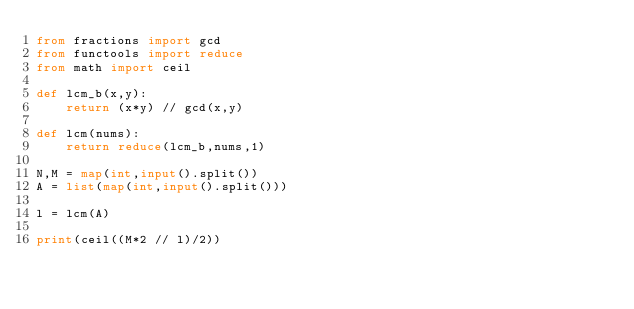<code> <loc_0><loc_0><loc_500><loc_500><_Python_>from fractions import gcd
from functools import reduce
from math import ceil

def lcm_b(x,y):
    return (x*y) // gcd(x,y)

def lcm(nums):
    return reduce(lcm_b,nums,1)

N,M = map(int,input().split())
A = list(map(int,input().split()))

l = lcm(A)

print(ceil((M*2 // l)/2))

</code> 